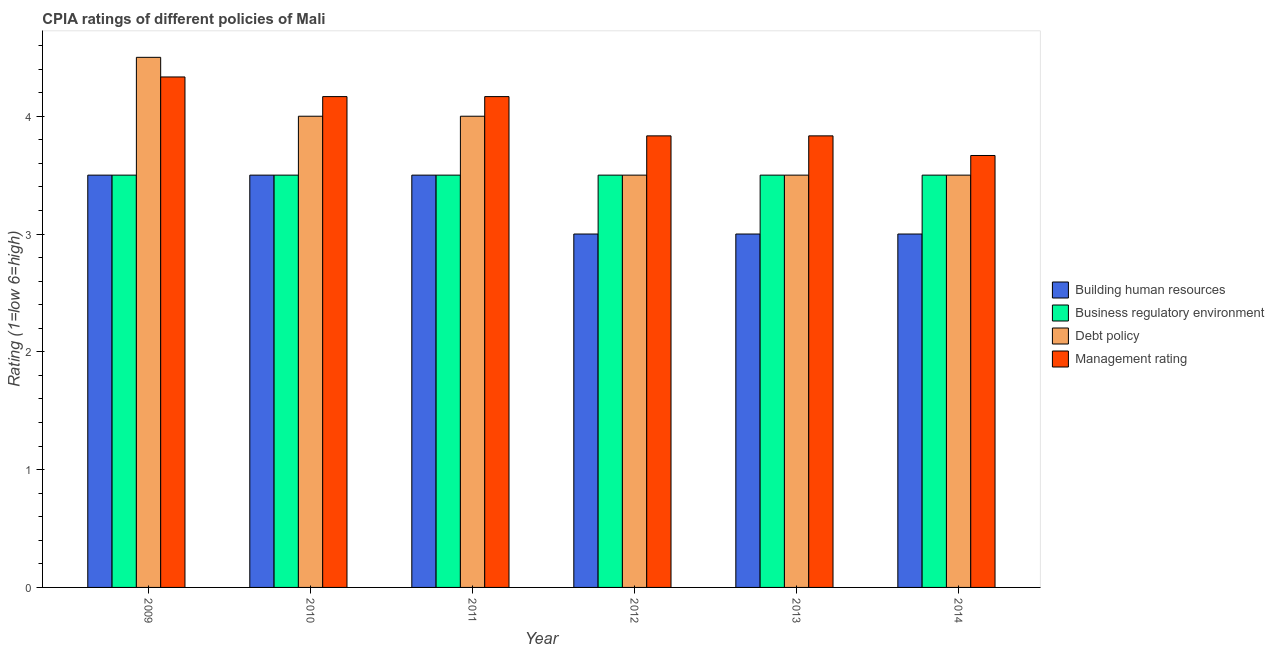How many different coloured bars are there?
Your response must be concise. 4. How many groups of bars are there?
Provide a short and direct response. 6. How many bars are there on the 6th tick from the right?
Your answer should be very brief. 4. What is the label of the 2nd group of bars from the left?
Your response must be concise. 2010. In how many cases, is the number of bars for a given year not equal to the number of legend labels?
Your response must be concise. 0. Across all years, what is the minimum cpia rating of management?
Keep it short and to the point. 3.67. In which year was the cpia rating of business regulatory environment maximum?
Make the answer very short. 2009. What is the total cpia rating of debt policy in the graph?
Make the answer very short. 23. In how many years, is the cpia rating of business regulatory environment greater than 3.8?
Offer a very short reply. 0. What is the ratio of the cpia rating of debt policy in 2010 to that in 2012?
Your answer should be very brief. 1.14. What is the difference between the highest and the second highest cpia rating of debt policy?
Offer a terse response. 0.5. In how many years, is the cpia rating of management greater than the average cpia rating of management taken over all years?
Offer a very short reply. 3. Is it the case that in every year, the sum of the cpia rating of debt policy and cpia rating of business regulatory environment is greater than the sum of cpia rating of management and cpia rating of building human resources?
Provide a short and direct response. No. What does the 1st bar from the left in 2009 represents?
Provide a short and direct response. Building human resources. What does the 3rd bar from the right in 2011 represents?
Offer a very short reply. Business regulatory environment. Are all the bars in the graph horizontal?
Provide a short and direct response. No. Are the values on the major ticks of Y-axis written in scientific E-notation?
Give a very brief answer. No. Does the graph contain any zero values?
Offer a very short reply. No. Does the graph contain grids?
Provide a succinct answer. No. Where does the legend appear in the graph?
Your answer should be compact. Center right. How are the legend labels stacked?
Give a very brief answer. Vertical. What is the title of the graph?
Your answer should be compact. CPIA ratings of different policies of Mali. What is the Rating (1=low 6=high) of Business regulatory environment in 2009?
Offer a very short reply. 3.5. What is the Rating (1=low 6=high) in Debt policy in 2009?
Provide a succinct answer. 4.5. What is the Rating (1=low 6=high) of Management rating in 2009?
Your answer should be compact. 4.33. What is the Rating (1=low 6=high) of Business regulatory environment in 2010?
Give a very brief answer. 3.5. What is the Rating (1=low 6=high) in Management rating in 2010?
Give a very brief answer. 4.17. What is the Rating (1=low 6=high) in Business regulatory environment in 2011?
Give a very brief answer. 3.5. What is the Rating (1=low 6=high) in Management rating in 2011?
Your answer should be compact. 4.17. What is the Rating (1=low 6=high) in Building human resources in 2012?
Provide a succinct answer. 3. What is the Rating (1=low 6=high) of Debt policy in 2012?
Keep it short and to the point. 3.5. What is the Rating (1=low 6=high) in Management rating in 2012?
Provide a short and direct response. 3.83. What is the Rating (1=low 6=high) in Management rating in 2013?
Provide a short and direct response. 3.83. What is the Rating (1=low 6=high) in Management rating in 2014?
Provide a succinct answer. 3.67. Across all years, what is the maximum Rating (1=low 6=high) of Building human resources?
Give a very brief answer. 3.5. Across all years, what is the maximum Rating (1=low 6=high) in Business regulatory environment?
Ensure brevity in your answer.  3.5. Across all years, what is the maximum Rating (1=low 6=high) in Management rating?
Keep it short and to the point. 4.33. Across all years, what is the minimum Rating (1=low 6=high) of Building human resources?
Your response must be concise. 3. Across all years, what is the minimum Rating (1=low 6=high) of Business regulatory environment?
Your answer should be very brief. 3.5. Across all years, what is the minimum Rating (1=low 6=high) of Debt policy?
Ensure brevity in your answer.  3.5. Across all years, what is the minimum Rating (1=low 6=high) in Management rating?
Make the answer very short. 3.67. What is the total Rating (1=low 6=high) of Building human resources in the graph?
Give a very brief answer. 19.5. What is the difference between the Rating (1=low 6=high) in Building human resources in 2009 and that in 2010?
Keep it short and to the point. 0. What is the difference between the Rating (1=low 6=high) in Business regulatory environment in 2009 and that in 2010?
Offer a very short reply. 0. What is the difference between the Rating (1=low 6=high) in Debt policy in 2009 and that in 2010?
Keep it short and to the point. 0.5. What is the difference between the Rating (1=low 6=high) in Building human resources in 2009 and that in 2011?
Provide a succinct answer. 0. What is the difference between the Rating (1=low 6=high) in Building human resources in 2009 and that in 2012?
Give a very brief answer. 0.5. What is the difference between the Rating (1=low 6=high) of Business regulatory environment in 2009 and that in 2012?
Ensure brevity in your answer.  0. What is the difference between the Rating (1=low 6=high) in Debt policy in 2009 and that in 2012?
Make the answer very short. 1. What is the difference between the Rating (1=low 6=high) of Building human resources in 2009 and that in 2013?
Your answer should be compact. 0.5. What is the difference between the Rating (1=low 6=high) of Business regulatory environment in 2009 and that in 2014?
Offer a terse response. 0. What is the difference between the Rating (1=low 6=high) of Debt policy in 2009 and that in 2014?
Your answer should be compact. 1. What is the difference between the Rating (1=low 6=high) in Management rating in 2009 and that in 2014?
Your answer should be compact. 0.67. What is the difference between the Rating (1=low 6=high) of Debt policy in 2010 and that in 2011?
Your response must be concise. 0. What is the difference between the Rating (1=low 6=high) in Business regulatory environment in 2010 and that in 2012?
Offer a very short reply. 0. What is the difference between the Rating (1=low 6=high) in Debt policy in 2010 and that in 2012?
Your response must be concise. 0.5. What is the difference between the Rating (1=low 6=high) in Management rating in 2010 and that in 2012?
Ensure brevity in your answer.  0.33. What is the difference between the Rating (1=low 6=high) in Management rating in 2010 and that in 2013?
Your answer should be very brief. 0.33. What is the difference between the Rating (1=low 6=high) of Business regulatory environment in 2010 and that in 2014?
Offer a terse response. 0. What is the difference between the Rating (1=low 6=high) of Management rating in 2010 and that in 2014?
Your answer should be very brief. 0.5. What is the difference between the Rating (1=low 6=high) of Building human resources in 2011 and that in 2012?
Keep it short and to the point. 0.5. What is the difference between the Rating (1=low 6=high) of Management rating in 2011 and that in 2012?
Offer a very short reply. 0.33. What is the difference between the Rating (1=low 6=high) in Building human resources in 2011 and that in 2013?
Provide a short and direct response. 0.5. What is the difference between the Rating (1=low 6=high) of Business regulatory environment in 2011 and that in 2013?
Provide a short and direct response. 0. What is the difference between the Rating (1=low 6=high) in Business regulatory environment in 2012 and that in 2013?
Provide a short and direct response. 0. What is the difference between the Rating (1=low 6=high) in Management rating in 2012 and that in 2014?
Keep it short and to the point. 0.17. What is the difference between the Rating (1=low 6=high) of Business regulatory environment in 2013 and that in 2014?
Provide a short and direct response. 0. What is the difference between the Rating (1=low 6=high) in Debt policy in 2013 and that in 2014?
Make the answer very short. 0. What is the difference between the Rating (1=low 6=high) of Building human resources in 2009 and the Rating (1=low 6=high) of Business regulatory environment in 2010?
Offer a very short reply. 0. What is the difference between the Rating (1=low 6=high) of Business regulatory environment in 2009 and the Rating (1=low 6=high) of Debt policy in 2010?
Keep it short and to the point. -0.5. What is the difference between the Rating (1=low 6=high) in Business regulatory environment in 2009 and the Rating (1=low 6=high) in Management rating in 2010?
Offer a very short reply. -0.67. What is the difference between the Rating (1=low 6=high) in Debt policy in 2009 and the Rating (1=low 6=high) in Management rating in 2010?
Keep it short and to the point. 0.33. What is the difference between the Rating (1=low 6=high) of Business regulatory environment in 2009 and the Rating (1=low 6=high) of Debt policy in 2011?
Offer a terse response. -0.5. What is the difference between the Rating (1=low 6=high) in Business regulatory environment in 2009 and the Rating (1=low 6=high) in Debt policy in 2012?
Your answer should be very brief. 0. What is the difference between the Rating (1=low 6=high) of Business regulatory environment in 2009 and the Rating (1=low 6=high) of Management rating in 2012?
Your answer should be very brief. -0.33. What is the difference between the Rating (1=low 6=high) of Building human resources in 2009 and the Rating (1=low 6=high) of Management rating in 2013?
Give a very brief answer. -0.33. What is the difference between the Rating (1=low 6=high) of Debt policy in 2009 and the Rating (1=low 6=high) of Management rating in 2013?
Ensure brevity in your answer.  0.67. What is the difference between the Rating (1=low 6=high) in Business regulatory environment in 2009 and the Rating (1=low 6=high) in Management rating in 2014?
Ensure brevity in your answer.  -0.17. What is the difference between the Rating (1=low 6=high) of Debt policy in 2009 and the Rating (1=low 6=high) of Management rating in 2014?
Give a very brief answer. 0.83. What is the difference between the Rating (1=low 6=high) of Building human resources in 2010 and the Rating (1=low 6=high) of Debt policy in 2011?
Provide a succinct answer. -0.5. What is the difference between the Rating (1=low 6=high) in Building human resources in 2010 and the Rating (1=low 6=high) in Management rating in 2011?
Provide a short and direct response. -0.67. What is the difference between the Rating (1=low 6=high) of Business regulatory environment in 2010 and the Rating (1=low 6=high) of Debt policy in 2011?
Keep it short and to the point. -0.5. What is the difference between the Rating (1=low 6=high) in Building human resources in 2010 and the Rating (1=low 6=high) in Business regulatory environment in 2012?
Provide a succinct answer. 0. What is the difference between the Rating (1=low 6=high) in Building human resources in 2010 and the Rating (1=low 6=high) in Debt policy in 2012?
Your answer should be compact. 0. What is the difference between the Rating (1=low 6=high) of Business regulatory environment in 2010 and the Rating (1=low 6=high) of Debt policy in 2012?
Your answer should be compact. 0. What is the difference between the Rating (1=low 6=high) in Business regulatory environment in 2010 and the Rating (1=low 6=high) in Management rating in 2012?
Provide a succinct answer. -0.33. What is the difference between the Rating (1=low 6=high) in Debt policy in 2010 and the Rating (1=low 6=high) in Management rating in 2012?
Offer a very short reply. 0.17. What is the difference between the Rating (1=low 6=high) in Building human resources in 2010 and the Rating (1=low 6=high) in Debt policy in 2013?
Your response must be concise. 0. What is the difference between the Rating (1=low 6=high) of Building human resources in 2010 and the Rating (1=low 6=high) of Management rating in 2013?
Your answer should be very brief. -0.33. What is the difference between the Rating (1=low 6=high) in Business regulatory environment in 2010 and the Rating (1=low 6=high) in Debt policy in 2013?
Your answer should be very brief. 0. What is the difference between the Rating (1=low 6=high) in Building human resources in 2010 and the Rating (1=low 6=high) in Business regulatory environment in 2014?
Provide a short and direct response. 0. What is the difference between the Rating (1=low 6=high) of Building human resources in 2010 and the Rating (1=low 6=high) of Debt policy in 2014?
Offer a terse response. 0. What is the difference between the Rating (1=low 6=high) in Building human resources in 2010 and the Rating (1=low 6=high) in Management rating in 2014?
Offer a terse response. -0.17. What is the difference between the Rating (1=low 6=high) in Business regulatory environment in 2010 and the Rating (1=low 6=high) in Debt policy in 2014?
Ensure brevity in your answer.  0. What is the difference between the Rating (1=low 6=high) in Business regulatory environment in 2010 and the Rating (1=low 6=high) in Management rating in 2014?
Make the answer very short. -0.17. What is the difference between the Rating (1=low 6=high) in Business regulatory environment in 2011 and the Rating (1=low 6=high) in Debt policy in 2012?
Your response must be concise. 0. What is the difference between the Rating (1=low 6=high) of Business regulatory environment in 2011 and the Rating (1=low 6=high) of Management rating in 2012?
Keep it short and to the point. -0.33. What is the difference between the Rating (1=low 6=high) of Debt policy in 2011 and the Rating (1=low 6=high) of Management rating in 2012?
Your answer should be compact. 0.17. What is the difference between the Rating (1=low 6=high) in Building human resources in 2011 and the Rating (1=low 6=high) in Business regulatory environment in 2013?
Give a very brief answer. 0. What is the difference between the Rating (1=low 6=high) in Building human resources in 2011 and the Rating (1=low 6=high) in Debt policy in 2013?
Offer a very short reply. 0. What is the difference between the Rating (1=low 6=high) in Building human resources in 2011 and the Rating (1=low 6=high) in Management rating in 2013?
Offer a very short reply. -0.33. What is the difference between the Rating (1=low 6=high) of Building human resources in 2011 and the Rating (1=low 6=high) of Business regulatory environment in 2014?
Provide a succinct answer. 0. What is the difference between the Rating (1=low 6=high) of Building human resources in 2011 and the Rating (1=low 6=high) of Debt policy in 2014?
Make the answer very short. 0. What is the difference between the Rating (1=low 6=high) in Building human resources in 2011 and the Rating (1=low 6=high) in Management rating in 2014?
Keep it short and to the point. -0.17. What is the difference between the Rating (1=low 6=high) of Business regulatory environment in 2011 and the Rating (1=low 6=high) of Management rating in 2014?
Keep it short and to the point. -0.17. What is the difference between the Rating (1=low 6=high) in Building human resources in 2012 and the Rating (1=low 6=high) in Debt policy in 2013?
Your answer should be very brief. -0.5. What is the difference between the Rating (1=low 6=high) of Building human resources in 2012 and the Rating (1=low 6=high) of Management rating in 2013?
Offer a terse response. -0.83. What is the difference between the Rating (1=low 6=high) of Business regulatory environment in 2012 and the Rating (1=low 6=high) of Debt policy in 2013?
Give a very brief answer. 0. What is the difference between the Rating (1=low 6=high) of Debt policy in 2012 and the Rating (1=low 6=high) of Management rating in 2013?
Provide a succinct answer. -0.33. What is the difference between the Rating (1=low 6=high) in Business regulatory environment in 2012 and the Rating (1=low 6=high) in Management rating in 2014?
Provide a short and direct response. -0.17. What is the difference between the Rating (1=low 6=high) of Debt policy in 2012 and the Rating (1=low 6=high) of Management rating in 2014?
Provide a succinct answer. -0.17. What is the difference between the Rating (1=low 6=high) of Building human resources in 2013 and the Rating (1=low 6=high) of Business regulatory environment in 2014?
Your answer should be very brief. -0.5. What is the difference between the Rating (1=low 6=high) of Building human resources in 2013 and the Rating (1=low 6=high) of Debt policy in 2014?
Your response must be concise. -0.5. What is the difference between the Rating (1=low 6=high) in Business regulatory environment in 2013 and the Rating (1=low 6=high) in Debt policy in 2014?
Your answer should be compact. 0. What is the difference between the Rating (1=low 6=high) in Business regulatory environment in 2013 and the Rating (1=low 6=high) in Management rating in 2014?
Offer a very short reply. -0.17. What is the difference between the Rating (1=low 6=high) of Debt policy in 2013 and the Rating (1=low 6=high) of Management rating in 2014?
Your response must be concise. -0.17. What is the average Rating (1=low 6=high) of Building human resources per year?
Your answer should be compact. 3.25. What is the average Rating (1=low 6=high) in Business regulatory environment per year?
Offer a terse response. 3.5. What is the average Rating (1=low 6=high) in Debt policy per year?
Give a very brief answer. 3.83. In the year 2009, what is the difference between the Rating (1=low 6=high) in Building human resources and Rating (1=low 6=high) in Business regulatory environment?
Your response must be concise. 0. In the year 2009, what is the difference between the Rating (1=low 6=high) of Building human resources and Rating (1=low 6=high) of Debt policy?
Your answer should be compact. -1. In the year 2009, what is the difference between the Rating (1=low 6=high) of Building human resources and Rating (1=low 6=high) of Management rating?
Provide a succinct answer. -0.83. In the year 2009, what is the difference between the Rating (1=low 6=high) of Business regulatory environment and Rating (1=low 6=high) of Debt policy?
Your answer should be compact. -1. In the year 2010, what is the difference between the Rating (1=low 6=high) of Building human resources and Rating (1=low 6=high) of Business regulatory environment?
Your response must be concise. 0. In the year 2010, what is the difference between the Rating (1=low 6=high) of Building human resources and Rating (1=low 6=high) of Debt policy?
Make the answer very short. -0.5. In the year 2010, what is the difference between the Rating (1=low 6=high) of Building human resources and Rating (1=low 6=high) of Management rating?
Ensure brevity in your answer.  -0.67. In the year 2010, what is the difference between the Rating (1=low 6=high) of Business regulatory environment and Rating (1=low 6=high) of Debt policy?
Offer a terse response. -0.5. In the year 2010, what is the difference between the Rating (1=low 6=high) of Business regulatory environment and Rating (1=low 6=high) of Management rating?
Your answer should be compact. -0.67. In the year 2010, what is the difference between the Rating (1=low 6=high) of Debt policy and Rating (1=low 6=high) of Management rating?
Keep it short and to the point. -0.17. In the year 2011, what is the difference between the Rating (1=low 6=high) in Building human resources and Rating (1=low 6=high) in Management rating?
Offer a terse response. -0.67. In the year 2011, what is the difference between the Rating (1=low 6=high) in Business regulatory environment and Rating (1=low 6=high) in Management rating?
Offer a terse response. -0.67. In the year 2012, what is the difference between the Rating (1=low 6=high) of Building human resources and Rating (1=low 6=high) of Business regulatory environment?
Your response must be concise. -0.5. In the year 2012, what is the difference between the Rating (1=low 6=high) in Building human resources and Rating (1=low 6=high) in Debt policy?
Ensure brevity in your answer.  -0.5. In the year 2012, what is the difference between the Rating (1=low 6=high) of Business regulatory environment and Rating (1=low 6=high) of Debt policy?
Your answer should be very brief. 0. In the year 2012, what is the difference between the Rating (1=low 6=high) of Business regulatory environment and Rating (1=low 6=high) of Management rating?
Your response must be concise. -0.33. In the year 2012, what is the difference between the Rating (1=low 6=high) of Debt policy and Rating (1=low 6=high) of Management rating?
Give a very brief answer. -0.33. In the year 2013, what is the difference between the Rating (1=low 6=high) of Building human resources and Rating (1=low 6=high) of Business regulatory environment?
Provide a succinct answer. -0.5. In the year 2013, what is the difference between the Rating (1=low 6=high) of Business regulatory environment and Rating (1=low 6=high) of Debt policy?
Offer a terse response. 0. In the year 2013, what is the difference between the Rating (1=low 6=high) in Debt policy and Rating (1=low 6=high) in Management rating?
Keep it short and to the point. -0.33. In the year 2014, what is the difference between the Rating (1=low 6=high) of Building human resources and Rating (1=low 6=high) of Debt policy?
Provide a succinct answer. -0.5. In the year 2014, what is the difference between the Rating (1=low 6=high) in Building human resources and Rating (1=low 6=high) in Management rating?
Provide a short and direct response. -0.67. In the year 2014, what is the difference between the Rating (1=low 6=high) in Debt policy and Rating (1=low 6=high) in Management rating?
Provide a short and direct response. -0.17. What is the ratio of the Rating (1=low 6=high) of Business regulatory environment in 2009 to that in 2010?
Ensure brevity in your answer.  1. What is the ratio of the Rating (1=low 6=high) in Debt policy in 2009 to that in 2010?
Make the answer very short. 1.12. What is the ratio of the Rating (1=low 6=high) of Management rating in 2009 to that in 2010?
Offer a very short reply. 1.04. What is the ratio of the Rating (1=low 6=high) in Business regulatory environment in 2009 to that in 2011?
Your answer should be compact. 1. What is the ratio of the Rating (1=low 6=high) of Debt policy in 2009 to that in 2011?
Your answer should be very brief. 1.12. What is the ratio of the Rating (1=low 6=high) in Business regulatory environment in 2009 to that in 2012?
Keep it short and to the point. 1. What is the ratio of the Rating (1=low 6=high) in Management rating in 2009 to that in 2012?
Make the answer very short. 1.13. What is the ratio of the Rating (1=low 6=high) in Business regulatory environment in 2009 to that in 2013?
Provide a short and direct response. 1. What is the ratio of the Rating (1=low 6=high) of Debt policy in 2009 to that in 2013?
Your response must be concise. 1.29. What is the ratio of the Rating (1=low 6=high) of Management rating in 2009 to that in 2013?
Keep it short and to the point. 1.13. What is the ratio of the Rating (1=low 6=high) in Building human resources in 2009 to that in 2014?
Your response must be concise. 1.17. What is the ratio of the Rating (1=low 6=high) in Business regulatory environment in 2009 to that in 2014?
Keep it short and to the point. 1. What is the ratio of the Rating (1=low 6=high) of Management rating in 2009 to that in 2014?
Make the answer very short. 1.18. What is the ratio of the Rating (1=low 6=high) of Business regulatory environment in 2010 to that in 2011?
Your response must be concise. 1. What is the ratio of the Rating (1=low 6=high) of Management rating in 2010 to that in 2011?
Provide a succinct answer. 1. What is the ratio of the Rating (1=low 6=high) in Business regulatory environment in 2010 to that in 2012?
Your answer should be very brief. 1. What is the ratio of the Rating (1=low 6=high) of Debt policy in 2010 to that in 2012?
Provide a succinct answer. 1.14. What is the ratio of the Rating (1=low 6=high) of Management rating in 2010 to that in 2012?
Keep it short and to the point. 1.09. What is the ratio of the Rating (1=low 6=high) of Building human resources in 2010 to that in 2013?
Your answer should be compact. 1.17. What is the ratio of the Rating (1=low 6=high) in Business regulatory environment in 2010 to that in 2013?
Your response must be concise. 1. What is the ratio of the Rating (1=low 6=high) of Debt policy in 2010 to that in 2013?
Ensure brevity in your answer.  1.14. What is the ratio of the Rating (1=low 6=high) in Management rating in 2010 to that in 2013?
Your answer should be very brief. 1.09. What is the ratio of the Rating (1=low 6=high) in Building human resources in 2010 to that in 2014?
Keep it short and to the point. 1.17. What is the ratio of the Rating (1=low 6=high) of Management rating in 2010 to that in 2014?
Your answer should be very brief. 1.14. What is the ratio of the Rating (1=low 6=high) in Building human resources in 2011 to that in 2012?
Your answer should be compact. 1.17. What is the ratio of the Rating (1=low 6=high) in Management rating in 2011 to that in 2012?
Give a very brief answer. 1.09. What is the ratio of the Rating (1=low 6=high) in Business regulatory environment in 2011 to that in 2013?
Offer a very short reply. 1. What is the ratio of the Rating (1=low 6=high) in Debt policy in 2011 to that in 2013?
Offer a terse response. 1.14. What is the ratio of the Rating (1=low 6=high) in Management rating in 2011 to that in 2013?
Give a very brief answer. 1.09. What is the ratio of the Rating (1=low 6=high) in Debt policy in 2011 to that in 2014?
Provide a short and direct response. 1.14. What is the ratio of the Rating (1=low 6=high) in Management rating in 2011 to that in 2014?
Offer a very short reply. 1.14. What is the ratio of the Rating (1=low 6=high) of Building human resources in 2012 to that in 2013?
Ensure brevity in your answer.  1. What is the ratio of the Rating (1=low 6=high) of Business regulatory environment in 2012 to that in 2013?
Offer a very short reply. 1. What is the ratio of the Rating (1=low 6=high) in Management rating in 2012 to that in 2013?
Provide a succinct answer. 1. What is the ratio of the Rating (1=low 6=high) of Building human resources in 2012 to that in 2014?
Give a very brief answer. 1. What is the ratio of the Rating (1=low 6=high) of Business regulatory environment in 2012 to that in 2014?
Provide a short and direct response. 1. What is the ratio of the Rating (1=low 6=high) of Debt policy in 2012 to that in 2014?
Provide a succinct answer. 1. What is the ratio of the Rating (1=low 6=high) in Management rating in 2012 to that in 2014?
Offer a terse response. 1.05. What is the ratio of the Rating (1=low 6=high) of Building human resources in 2013 to that in 2014?
Your answer should be compact. 1. What is the ratio of the Rating (1=low 6=high) in Management rating in 2013 to that in 2014?
Make the answer very short. 1.05. What is the difference between the highest and the second highest Rating (1=low 6=high) in Business regulatory environment?
Your response must be concise. 0. What is the difference between the highest and the second highest Rating (1=low 6=high) of Debt policy?
Make the answer very short. 0.5. What is the difference between the highest and the second highest Rating (1=low 6=high) in Management rating?
Your response must be concise. 0.17. What is the difference between the highest and the lowest Rating (1=low 6=high) of Building human resources?
Make the answer very short. 0.5. What is the difference between the highest and the lowest Rating (1=low 6=high) of Business regulatory environment?
Give a very brief answer. 0. What is the difference between the highest and the lowest Rating (1=low 6=high) in Debt policy?
Your response must be concise. 1. What is the difference between the highest and the lowest Rating (1=low 6=high) in Management rating?
Your response must be concise. 0.67. 